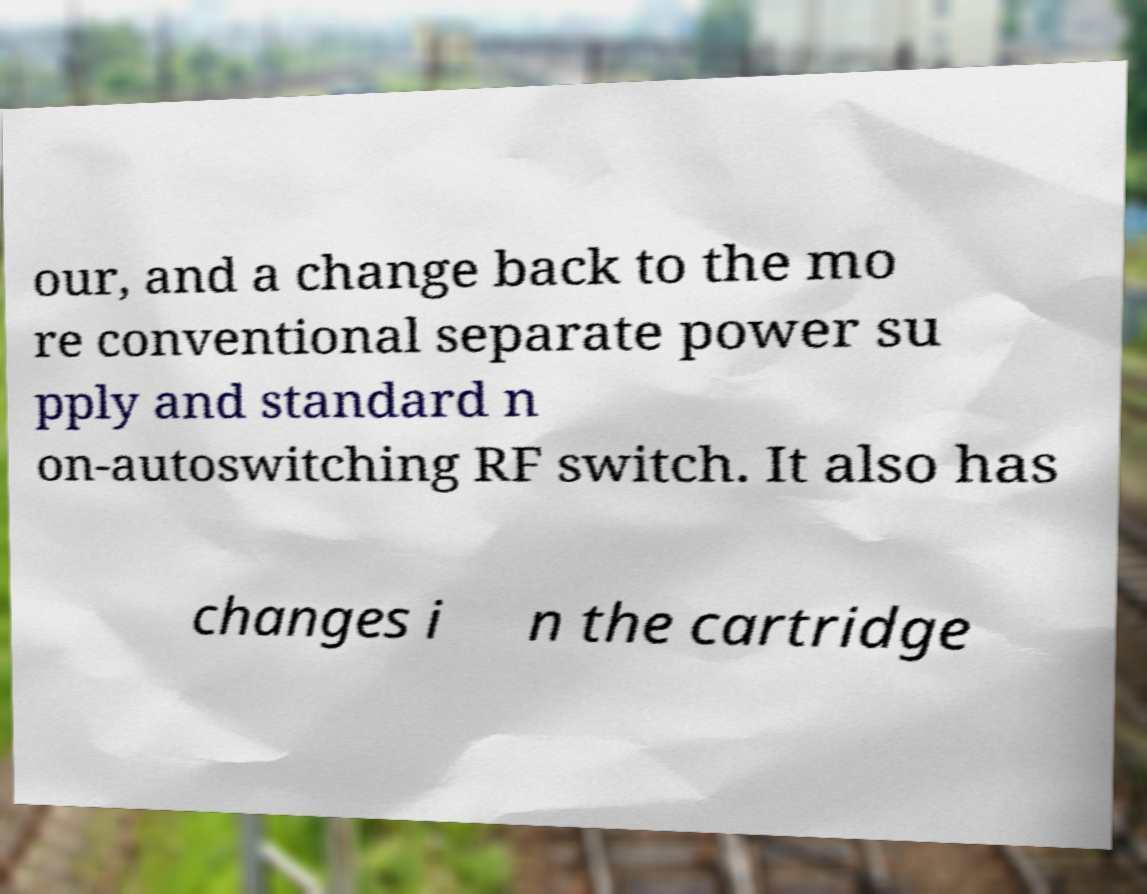For documentation purposes, I need the text within this image transcribed. Could you provide that? our, and a change back to the mo re conventional separate power su pply and standard n on-autoswitching RF switch. It also has changes i n the cartridge 